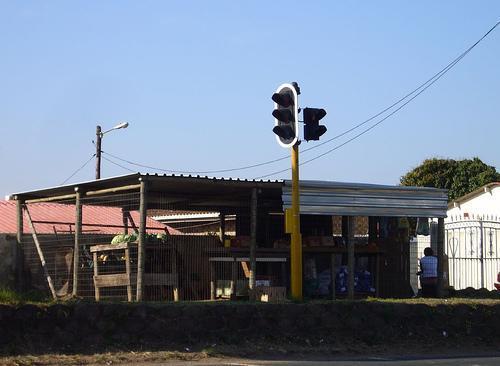How many toy mice have a sign?
Give a very brief answer. 0. 